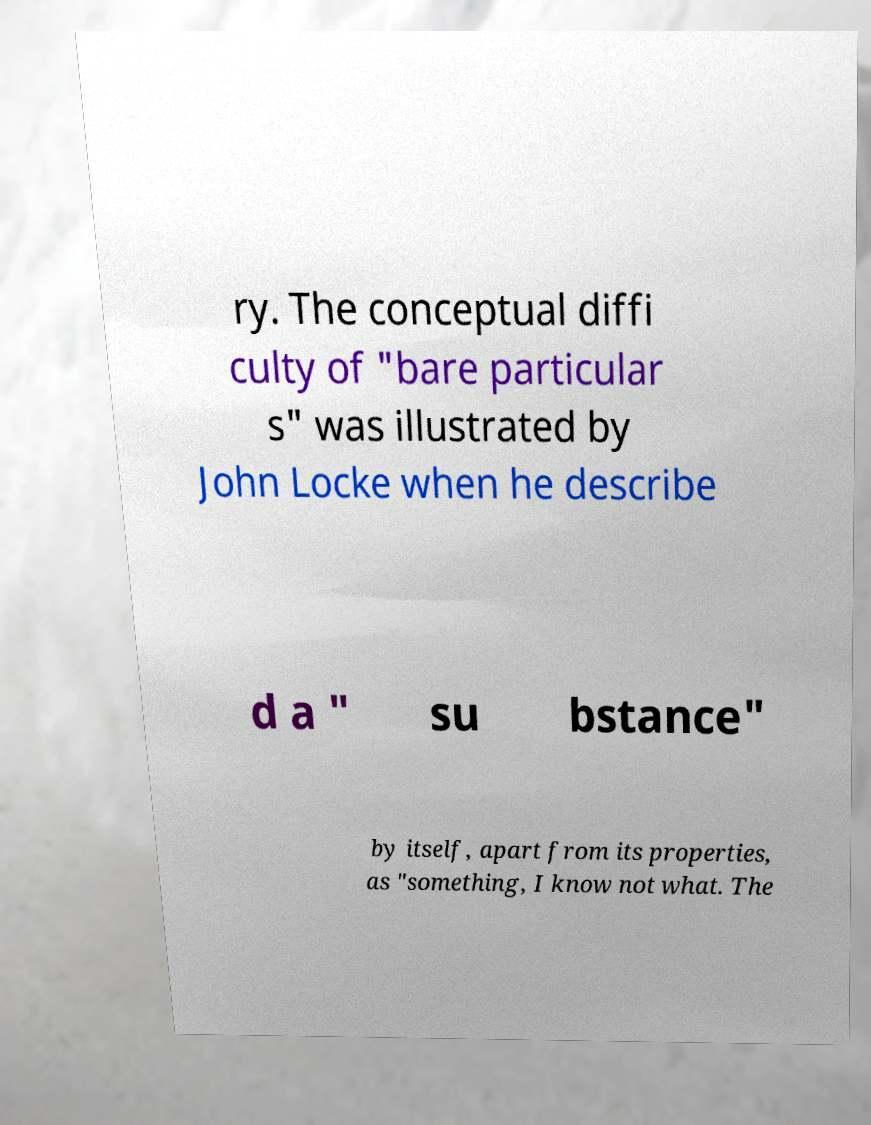Please identify and transcribe the text found in this image. ry. The conceptual diffi culty of "bare particular s" was illustrated by John Locke when he describe d a " su bstance" by itself, apart from its properties, as "something, I know not what. The 